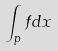<formula> <loc_0><loc_0><loc_500><loc_500>\int _ { p } f d x</formula> 